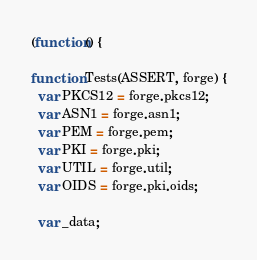<code> <loc_0><loc_0><loc_500><loc_500><_JavaScript_>(function() {

function Tests(ASSERT, forge) {
  var PKCS12 = forge.pkcs12;
  var ASN1 = forge.asn1;
  var PEM = forge.pem;
  var PKI = forge.pki;
  var UTIL = forge.util;
  var OIDS = forge.pki.oids;

  var _data;</code> 